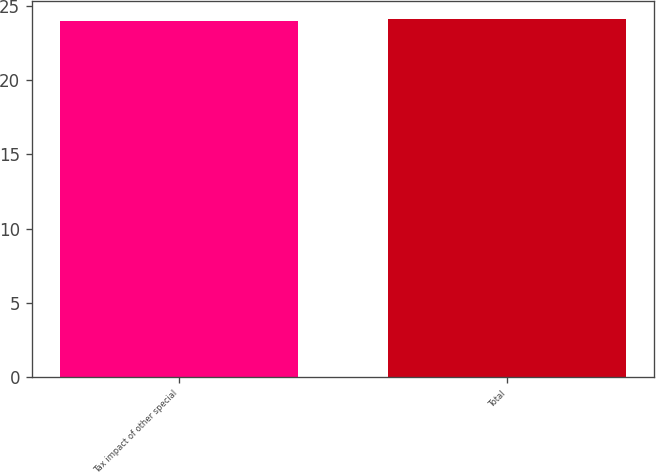Convert chart. <chart><loc_0><loc_0><loc_500><loc_500><bar_chart><fcel>Tax impact of other special<fcel>Total<nl><fcel>24<fcel>24.1<nl></chart> 